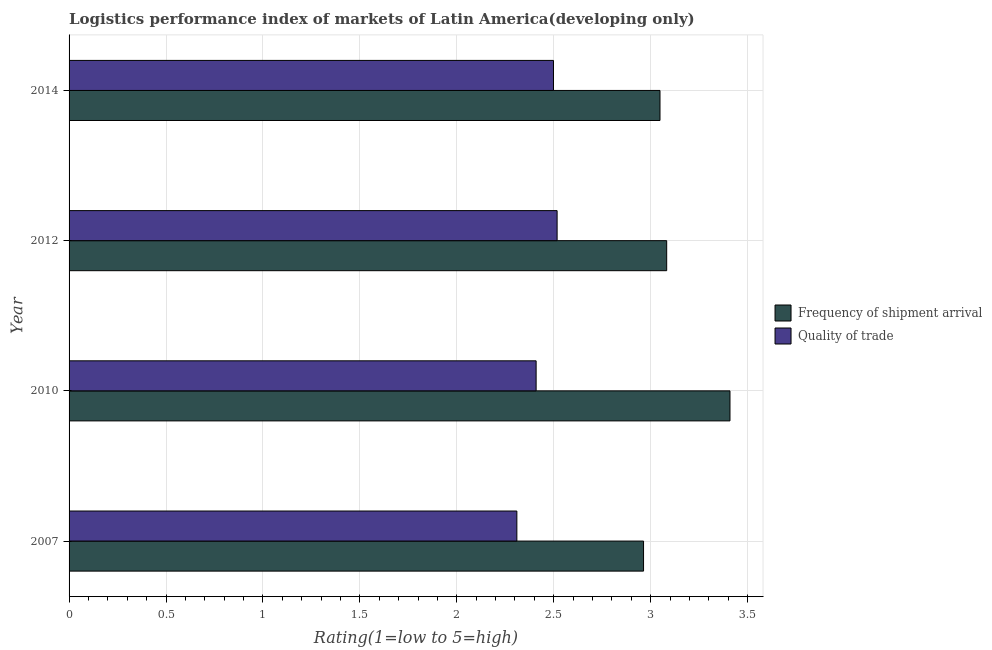How many different coloured bars are there?
Your answer should be compact. 2. Are the number of bars per tick equal to the number of legend labels?
Provide a short and direct response. Yes. Are the number of bars on each tick of the Y-axis equal?
Provide a short and direct response. Yes. How many bars are there on the 3rd tick from the top?
Keep it short and to the point. 2. How many bars are there on the 4th tick from the bottom?
Your response must be concise. 2. In how many cases, is the number of bars for a given year not equal to the number of legend labels?
Provide a succinct answer. 0. What is the lpi of frequency of shipment arrival in 2012?
Offer a terse response. 3.08. Across all years, what is the maximum lpi quality of trade?
Ensure brevity in your answer.  2.52. Across all years, what is the minimum lpi quality of trade?
Make the answer very short. 2.31. In which year was the lpi of frequency of shipment arrival minimum?
Offer a very short reply. 2007. What is the total lpi quality of trade in the graph?
Provide a succinct answer. 9.74. What is the difference between the lpi quality of trade in 2007 and that in 2010?
Ensure brevity in your answer.  -0.1. What is the difference between the lpi quality of trade in 2007 and the lpi of frequency of shipment arrival in 2014?
Your answer should be compact. -0.74. What is the average lpi of frequency of shipment arrival per year?
Provide a short and direct response. 3.13. In the year 2012, what is the difference between the lpi quality of trade and lpi of frequency of shipment arrival?
Your response must be concise. -0.56. In how many years, is the lpi quality of trade greater than 2.7 ?
Your answer should be very brief. 0. What is the ratio of the lpi of frequency of shipment arrival in 2007 to that in 2010?
Provide a short and direct response. 0.87. What is the difference between the highest and the second highest lpi quality of trade?
Offer a very short reply. 0.02. What is the difference between the highest and the lowest lpi quality of trade?
Provide a short and direct response. 0.21. What does the 1st bar from the top in 2012 represents?
Make the answer very short. Quality of trade. What does the 1st bar from the bottom in 2010 represents?
Ensure brevity in your answer.  Frequency of shipment arrival. How many bars are there?
Keep it short and to the point. 8. How many years are there in the graph?
Give a very brief answer. 4. Are the values on the major ticks of X-axis written in scientific E-notation?
Make the answer very short. No. Does the graph contain any zero values?
Your answer should be very brief. No. Does the graph contain grids?
Give a very brief answer. Yes. Where does the legend appear in the graph?
Give a very brief answer. Center right. How are the legend labels stacked?
Your response must be concise. Vertical. What is the title of the graph?
Give a very brief answer. Logistics performance index of markets of Latin America(developing only). What is the label or title of the X-axis?
Make the answer very short. Rating(1=low to 5=high). What is the Rating(1=low to 5=high) of Frequency of shipment arrival in 2007?
Give a very brief answer. 2.96. What is the Rating(1=low to 5=high) in Quality of trade in 2007?
Provide a short and direct response. 2.31. What is the Rating(1=low to 5=high) in Frequency of shipment arrival in 2010?
Provide a succinct answer. 3.41. What is the Rating(1=low to 5=high) of Quality of trade in 2010?
Give a very brief answer. 2.41. What is the Rating(1=low to 5=high) in Frequency of shipment arrival in 2012?
Give a very brief answer. 3.08. What is the Rating(1=low to 5=high) in Quality of trade in 2012?
Your answer should be very brief. 2.52. What is the Rating(1=low to 5=high) of Frequency of shipment arrival in 2014?
Your response must be concise. 3.05. What is the Rating(1=low to 5=high) of Quality of trade in 2014?
Your response must be concise. 2.5. Across all years, what is the maximum Rating(1=low to 5=high) of Frequency of shipment arrival?
Offer a terse response. 3.41. Across all years, what is the maximum Rating(1=low to 5=high) in Quality of trade?
Offer a very short reply. 2.52. Across all years, what is the minimum Rating(1=low to 5=high) in Frequency of shipment arrival?
Your answer should be very brief. 2.96. Across all years, what is the minimum Rating(1=low to 5=high) in Quality of trade?
Your response must be concise. 2.31. What is the total Rating(1=low to 5=high) of Frequency of shipment arrival in the graph?
Your answer should be compact. 12.5. What is the total Rating(1=low to 5=high) of Quality of trade in the graph?
Provide a short and direct response. 9.74. What is the difference between the Rating(1=low to 5=high) of Frequency of shipment arrival in 2007 and that in 2010?
Keep it short and to the point. -0.45. What is the difference between the Rating(1=low to 5=high) of Quality of trade in 2007 and that in 2010?
Make the answer very short. -0.1. What is the difference between the Rating(1=low to 5=high) of Frequency of shipment arrival in 2007 and that in 2012?
Make the answer very short. -0.12. What is the difference between the Rating(1=low to 5=high) in Quality of trade in 2007 and that in 2012?
Your answer should be very brief. -0.21. What is the difference between the Rating(1=low to 5=high) in Frequency of shipment arrival in 2007 and that in 2014?
Offer a terse response. -0.08. What is the difference between the Rating(1=low to 5=high) of Quality of trade in 2007 and that in 2014?
Make the answer very short. -0.19. What is the difference between the Rating(1=low to 5=high) of Frequency of shipment arrival in 2010 and that in 2012?
Keep it short and to the point. 0.33. What is the difference between the Rating(1=low to 5=high) in Quality of trade in 2010 and that in 2012?
Make the answer very short. -0.11. What is the difference between the Rating(1=low to 5=high) of Frequency of shipment arrival in 2010 and that in 2014?
Provide a succinct answer. 0.36. What is the difference between the Rating(1=low to 5=high) in Quality of trade in 2010 and that in 2014?
Make the answer very short. -0.09. What is the difference between the Rating(1=low to 5=high) in Frequency of shipment arrival in 2012 and that in 2014?
Provide a succinct answer. 0.03. What is the difference between the Rating(1=low to 5=high) of Quality of trade in 2012 and that in 2014?
Provide a short and direct response. 0.02. What is the difference between the Rating(1=low to 5=high) of Frequency of shipment arrival in 2007 and the Rating(1=low to 5=high) of Quality of trade in 2010?
Your answer should be very brief. 0.55. What is the difference between the Rating(1=low to 5=high) in Frequency of shipment arrival in 2007 and the Rating(1=low to 5=high) in Quality of trade in 2012?
Provide a short and direct response. 0.45. What is the difference between the Rating(1=low to 5=high) of Frequency of shipment arrival in 2007 and the Rating(1=low to 5=high) of Quality of trade in 2014?
Ensure brevity in your answer.  0.46. What is the difference between the Rating(1=low to 5=high) of Frequency of shipment arrival in 2010 and the Rating(1=low to 5=high) of Quality of trade in 2012?
Ensure brevity in your answer.  0.89. What is the difference between the Rating(1=low to 5=high) of Frequency of shipment arrival in 2010 and the Rating(1=low to 5=high) of Quality of trade in 2014?
Provide a short and direct response. 0.91. What is the difference between the Rating(1=low to 5=high) in Frequency of shipment arrival in 2012 and the Rating(1=low to 5=high) in Quality of trade in 2014?
Offer a very short reply. 0.58. What is the average Rating(1=low to 5=high) in Frequency of shipment arrival per year?
Give a very brief answer. 3.13. What is the average Rating(1=low to 5=high) in Quality of trade per year?
Make the answer very short. 2.43. In the year 2007, what is the difference between the Rating(1=low to 5=high) in Frequency of shipment arrival and Rating(1=low to 5=high) in Quality of trade?
Offer a very short reply. 0.65. In the year 2010, what is the difference between the Rating(1=low to 5=high) of Frequency of shipment arrival and Rating(1=low to 5=high) of Quality of trade?
Make the answer very short. 1. In the year 2012, what is the difference between the Rating(1=low to 5=high) in Frequency of shipment arrival and Rating(1=low to 5=high) in Quality of trade?
Ensure brevity in your answer.  0.57. In the year 2014, what is the difference between the Rating(1=low to 5=high) of Frequency of shipment arrival and Rating(1=low to 5=high) of Quality of trade?
Ensure brevity in your answer.  0.55. What is the ratio of the Rating(1=low to 5=high) of Frequency of shipment arrival in 2007 to that in 2010?
Provide a succinct answer. 0.87. What is the ratio of the Rating(1=low to 5=high) of Quality of trade in 2007 to that in 2010?
Give a very brief answer. 0.96. What is the ratio of the Rating(1=low to 5=high) in Frequency of shipment arrival in 2007 to that in 2012?
Provide a short and direct response. 0.96. What is the ratio of the Rating(1=low to 5=high) of Quality of trade in 2007 to that in 2012?
Offer a terse response. 0.92. What is the ratio of the Rating(1=low to 5=high) in Frequency of shipment arrival in 2007 to that in 2014?
Offer a terse response. 0.97. What is the ratio of the Rating(1=low to 5=high) of Quality of trade in 2007 to that in 2014?
Provide a succinct answer. 0.92. What is the ratio of the Rating(1=low to 5=high) of Frequency of shipment arrival in 2010 to that in 2012?
Provide a succinct answer. 1.11. What is the ratio of the Rating(1=low to 5=high) in Frequency of shipment arrival in 2010 to that in 2014?
Provide a short and direct response. 1.12. What is the ratio of the Rating(1=low to 5=high) of Quality of trade in 2010 to that in 2014?
Provide a succinct answer. 0.96. What is the ratio of the Rating(1=low to 5=high) of Frequency of shipment arrival in 2012 to that in 2014?
Your answer should be compact. 1.01. What is the ratio of the Rating(1=low to 5=high) in Quality of trade in 2012 to that in 2014?
Your answer should be compact. 1.01. What is the difference between the highest and the second highest Rating(1=low to 5=high) of Frequency of shipment arrival?
Offer a very short reply. 0.33. What is the difference between the highest and the second highest Rating(1=low to 5=high) in Quality of trade?
Provide a short and direct response. 0.02. What is the difference between the highest and the lowest Rating(1=low to 5=high) in Frequency of shipment arrival?
Ensure brevity in your answer.  0.45. What is the difference between the highest and the lowest Rating(1=low to 5=high) of Quality of trade?
Provide a succinct answer. 0.21. 